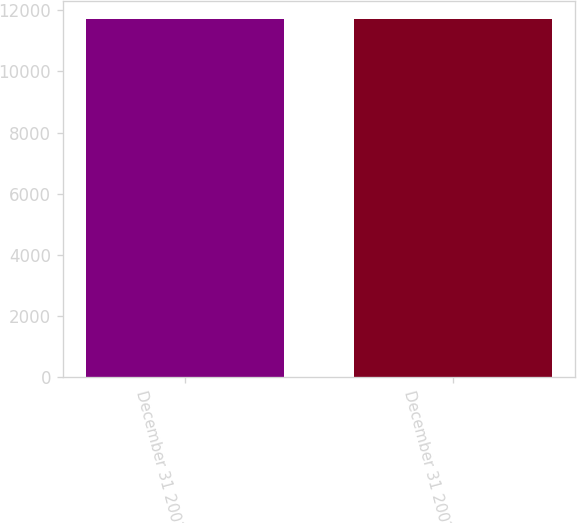<chart> <loc_0><loc_0><loc_500><loc_500><bar_chart><fcel>December 31 2001<fcel>December 31 2002<nl><fcel>11722<fcel>11722.1<nl></chart> 